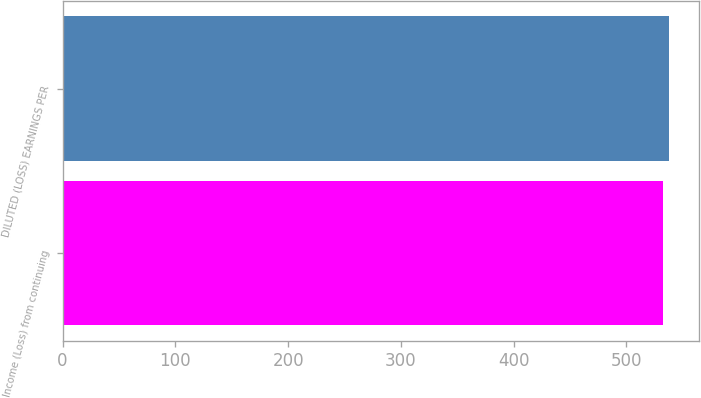<chart> <loc_0><loc_0><loc_500><loc_500><bar_chart><fcel>Income (Loss) from continuing<fcel>DILUTED (LOSS) EARNINGS PER<nl><fcel>532.2<fcel>537.9<nl></chart> 